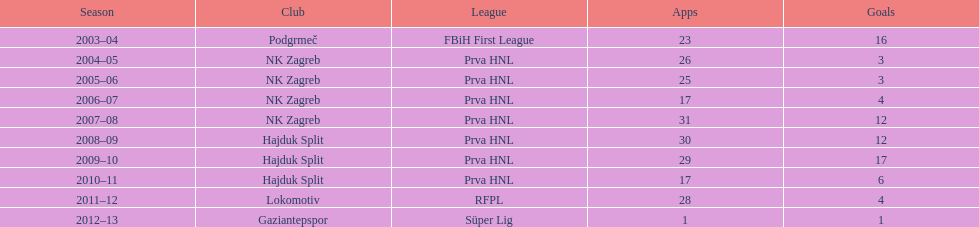In the 2004-2005 season, what was the total number of goals scored given that there were no more than 26 apps? 3. 